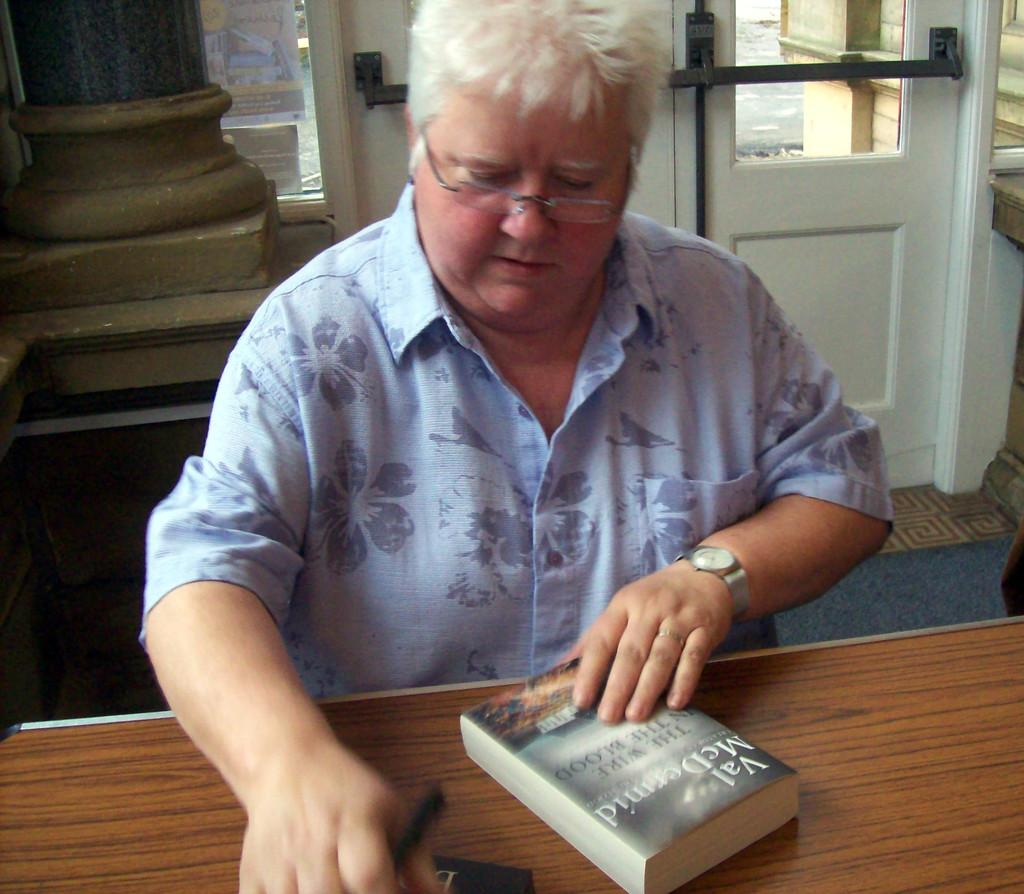What structure is visible in the image that allows access to different areas? There is a door in the image. What vertical object can be seen in the image? There is a pole in the image. Who or what is present in the image? There is a person standing in the image. What piece of furniture is in the image? There is a table in the image. What object related to reading is on the table? There is a book on the table. How does the person in the image pay attention to the water? There is no water present in the image, so the person cannot pay attention to it. What type of ear is visible on the person in the image? There is no ear visible on the person in the image. 